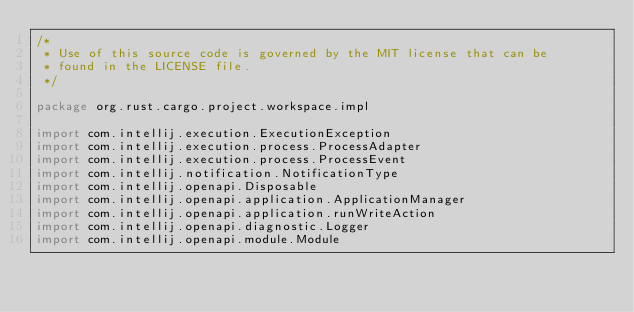Convert code to text. <code><loc_0><loc_0><loc_500><loc_500><_Kotlin_>/*
 * Use of this source code is governed by the MIT license that can be
 * found in the LICENSE file.
 */

package org.rust.cargo.project.workspace.impl

import com.intellij.execution.ExecutionException
import com.intellij.execution.process.ProcessAdapter
import com.intellij.execution.process.ProcessEvent
import com.intellij.notification.NotificationType
import com.intellij.openapi.Disposable
import com.intellij.openapi.application.ApplicationManager
import com.intellij.openapi.application.runWriteAction
import com.intellij.openapi.diagnostic.Logger
import com.intellij.openapi.module.Module</code> 